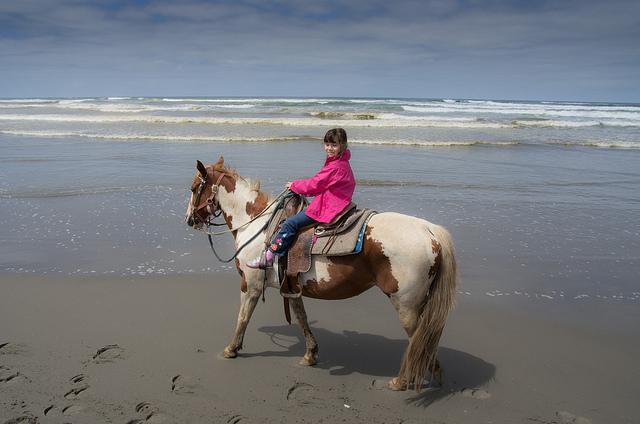How many people are looking towards the photographer?
Answer briefly. 1. What color is the girls coat?
Give a very brief answer. Pink. How many people are there?
Quick response, please. 1. What color is the horse?
Concise answer only. White and brown. What is the girl looking at?
Keep it brief. Camera. Is that a mountain in the background?
Be succinct. No. 